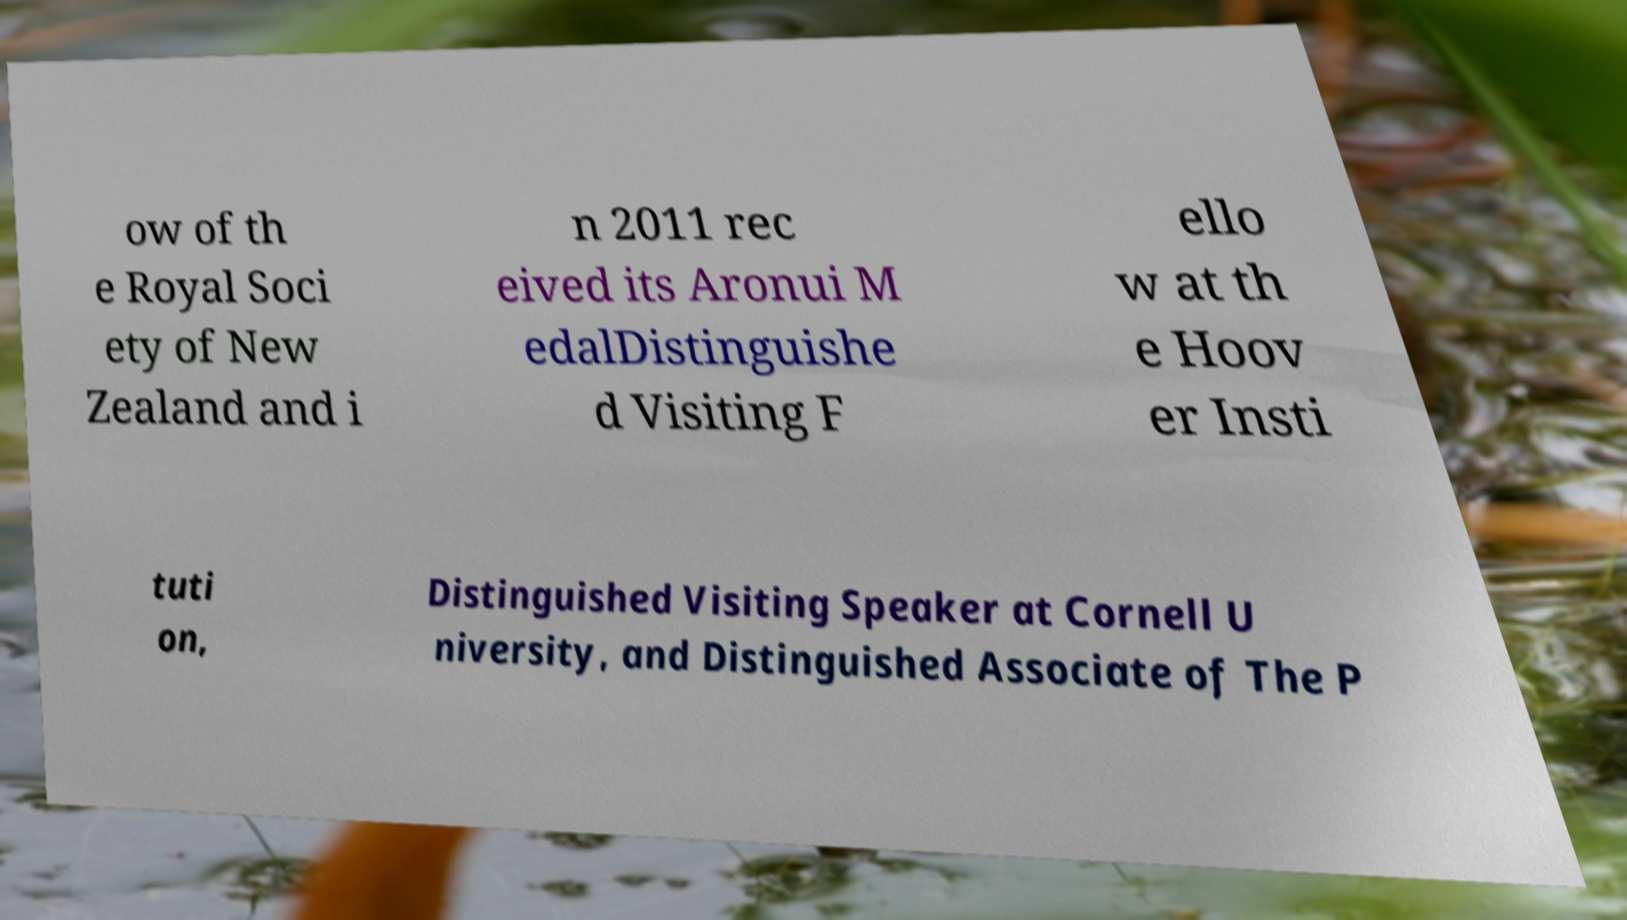I need the written content from this picture converted into text. Can you do that? ow of th e Royal Soci ety of New Zealand and i n 2011 rec eived its Aronui M edalDistinguishe d Visiting F ello w at th e Hoov er Insti tuti on, Distinguished Visiting Speaker at Cornell U niversity, and Distinguished Associate of The P 